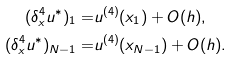<formula> <loc_0><loc_0><loc_500><loc_500>( \delta _ { x } ^ { 4 } u ^ { \ast } ) _ { 1 } = & u ^ { ( 4 ) } ( x _ { 1 } ) + O ( h ) , \\ ( \delta _ { x } ^ { 4 } u ^ { \ast } ) _ { N - 1 } = & u ^ { ( 4 ) } ( x _ { N - 1 } ) + O ( h ) .</formula> 